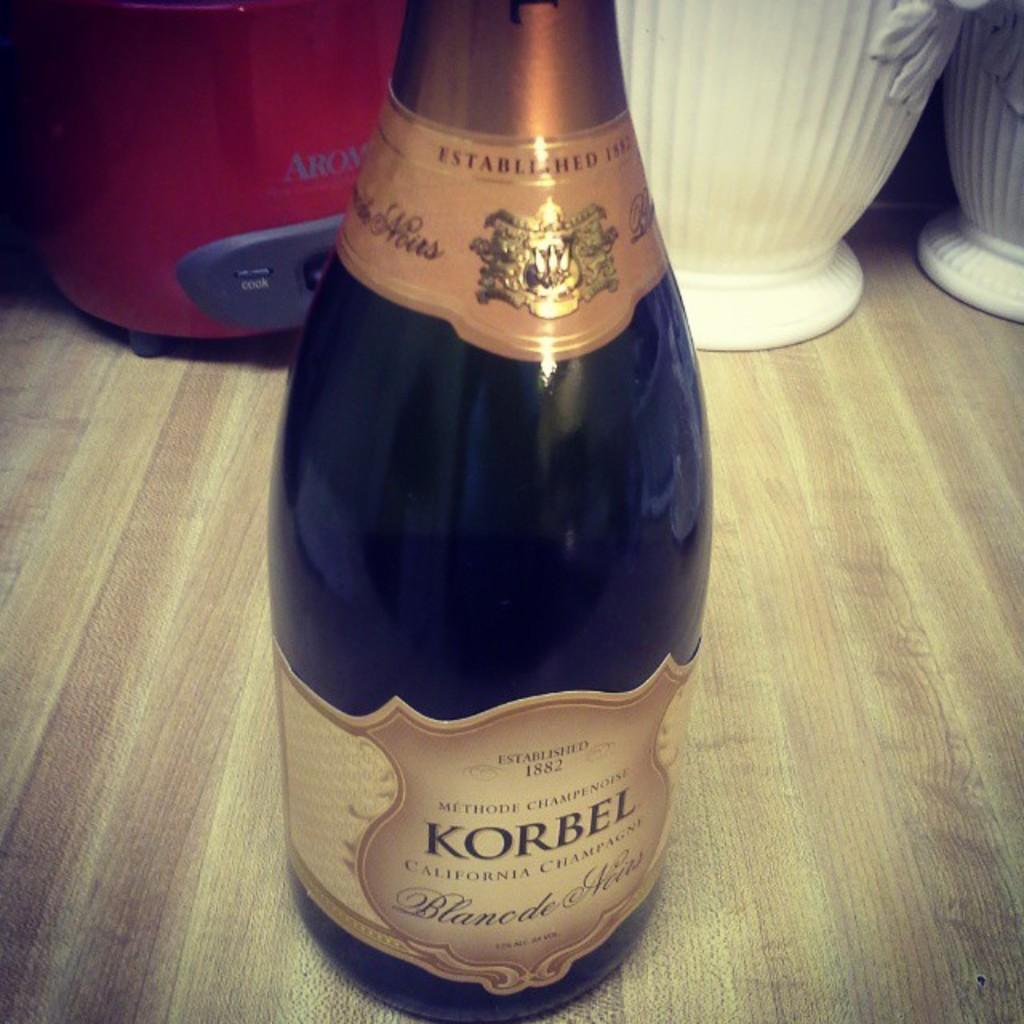<image>
Summarize the visual content of the image. A bottle of Korbel is placed on a countertop. 